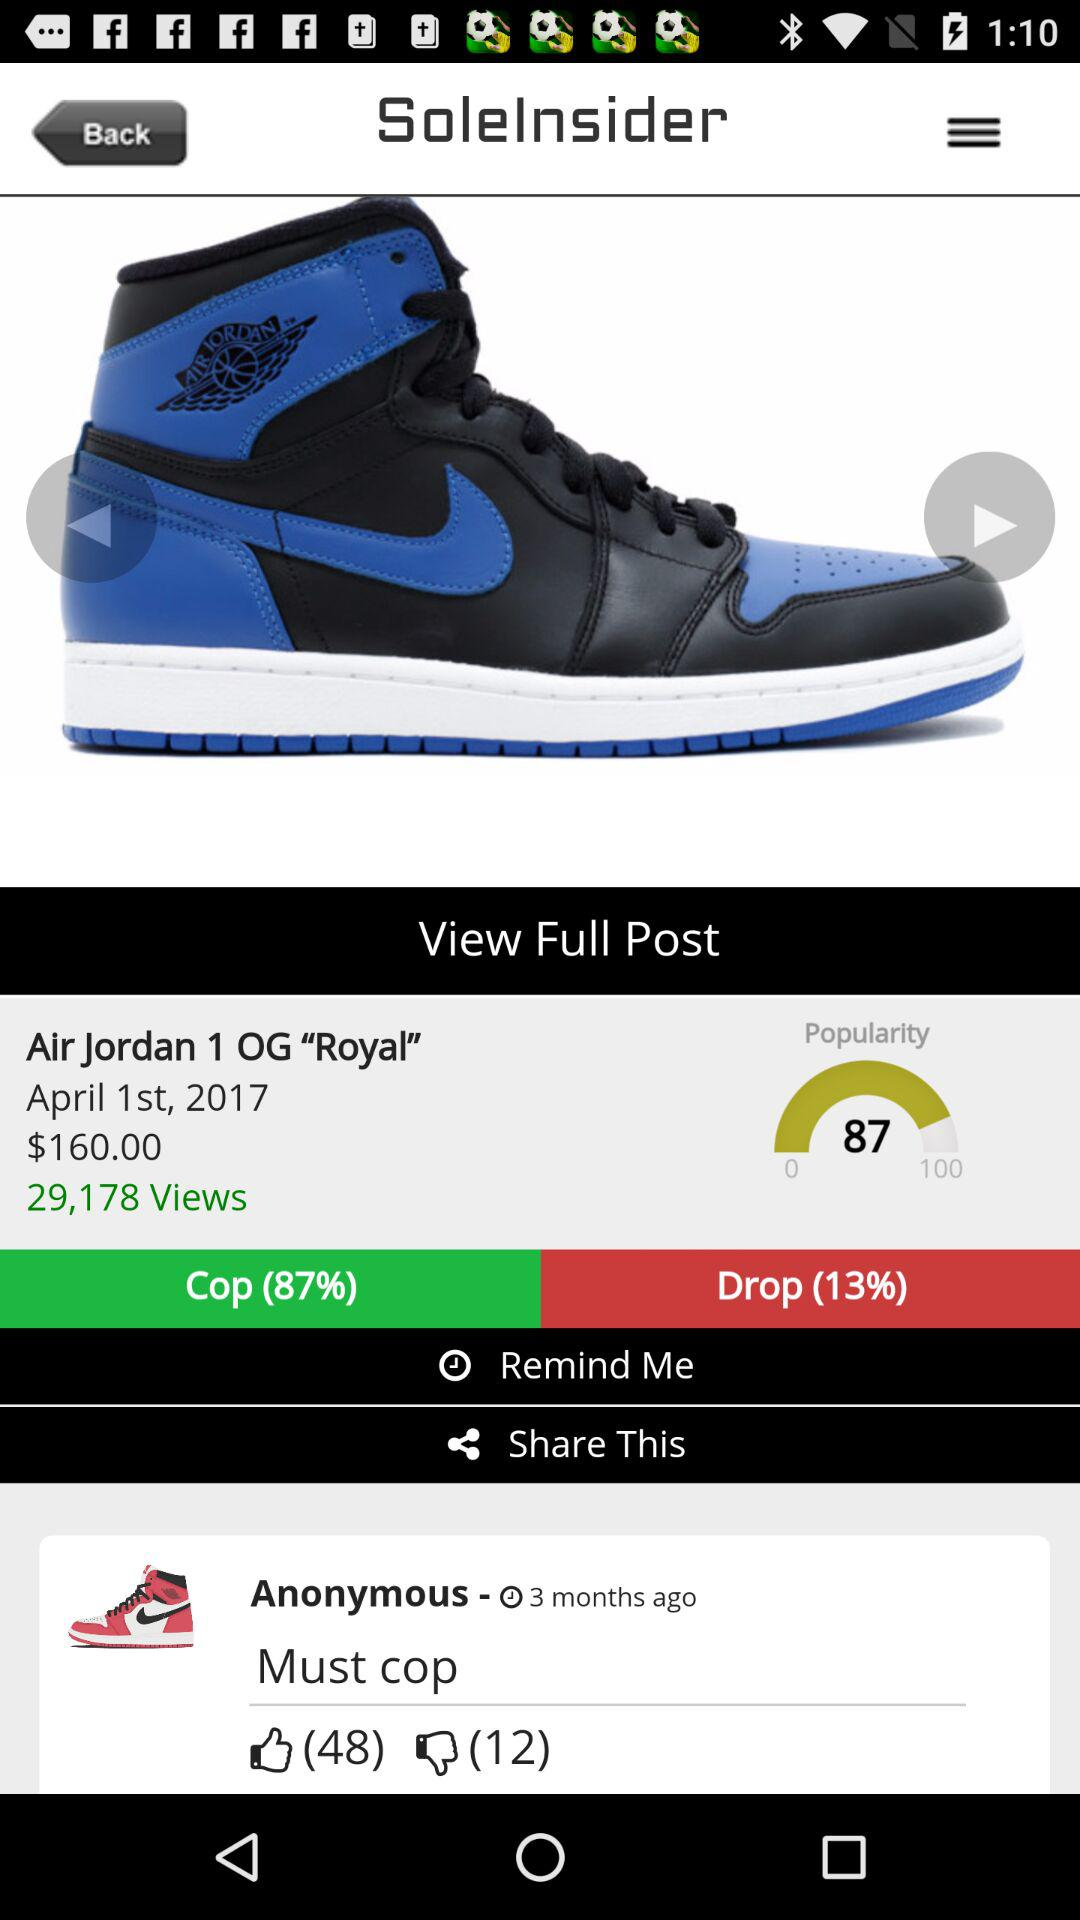What is the popularity of "Air Jordan 1 OG "Royal""? The popularity is 87. 